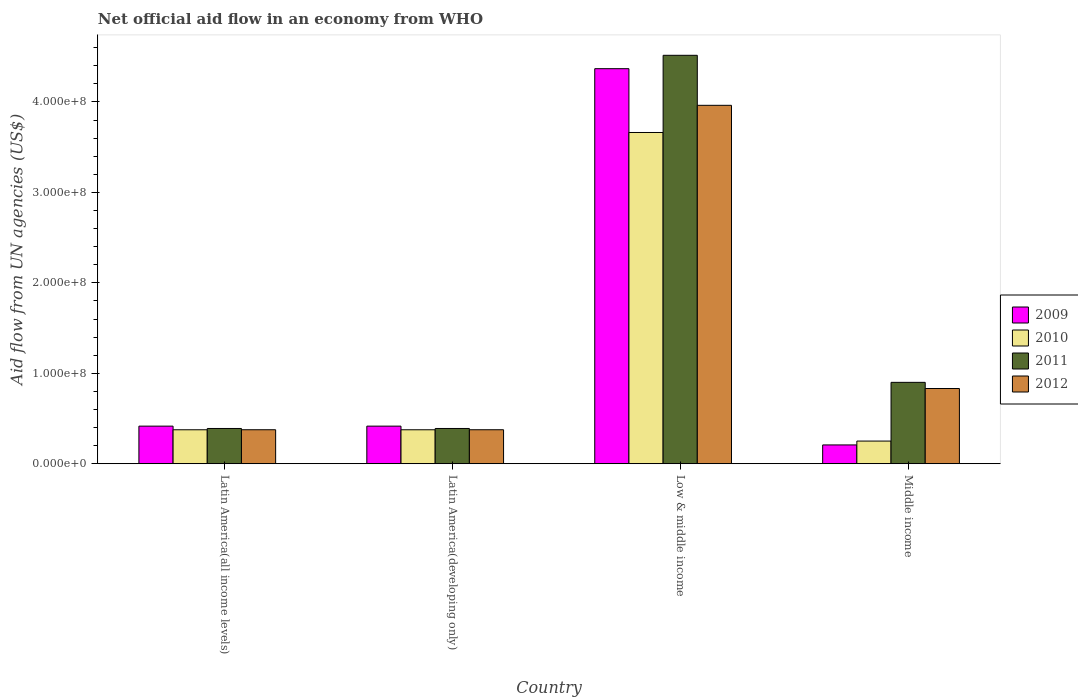How many groups of bars are there?
Offer a very short reply. 4. Are the number of bars per tick equal to the number of legend labels?
Provide a short and direct response. Yes. How many bars are there on the 1st tick from the left?
Offer a terse response. 4. How many bars are there on the 1st tick from the right?
Your response must be concise. 4. What is the label of the 1st group of bars from the left?
Offer a terse response. Latin America(all income levels). What is the net official aid flow in 2010 in Latin America(developing only)?
Provide a succinct answer. 3.76e+07. Across all countries, what is the maximum net official aid flow in 2012?
Your response must be concise. 3.96e+08. Across all countries, what is the minimum net official aid flow in 2009?
Offer a terse response. 2.08e+07. What is the total net official aid flow in 2009 in the graph?
Ensure brevity in your answer.  5.41e+08. What is the difference between the net official aid flow in 2009 in Latin America(all income levels) and that in Latin America(developing only)?
Offer a terse response. 0. What is the difference between the net official aid flow in 2010 in Middle income and the net official aid flow in 2011 in Latin America(all income levels)?
Keep it short and to the point. -1.39e+07. What is the average net official aid flow in 2009 per country?
Give a very brief answer. 1.35e+08. What is the difference between the net official aid flow of/in 2009 and net official aid flow of/in 2012 in Latin America(developing only)?
Provide a succinct answer. 3.99e+06. In how many countries, is the net official aid flow in 2011 greater than 320000000 US$?
Provide a succinct answer. 1. What is the ratio of the net official aid flow in 2009 in Low & middle income to that in Middle income?
Provide a short and direct response. 21. Is the net official aid flow in 2012 in Latin America(developing only) less than that in Low & middle income?
Give a very brief answer. Yes. What is the difference between the highest and the second highest net official aid flow in 2009?
Provide a short and direct response. 3.95e+08. What is the difference between the highest and the lowest net official aid flow in 2010?
Ensure brevity in your answer.  3.41e+08. Is the sum of the net official aid flow in 2010 in Latin America(developing only) and Low & middle income greater than the maximum net official aid flow in 2012 across all countries?
Your response must be concise. Yes. What does the 3rd bar from the left in Latin America(all income levels) represents?
Give a very brief answer. 2011. What does the 4th bar from the right in Middle income represents?
Your response must be concise. 2009. How many bars are there?
Ensure brevity in your answer.  16. Are all the bars in the graph horizontal?
Provide a short and direct response. No. Are the values on the major ticks of Y-axis written in scientific E-notation?
Keep it short and to the point. Yes. Does the graph contain any zero values?
Offer a very short reply. No. How many legend labels are there?
Your answer should be very brief. 4. How are the legend labels stacked?
Offer a terse response. Vertical. What is the title of the graph?
Offer a very short reply. Net official aid flow in an economy from WHO. What is the label or title of the X-axis?
Provide a short and direct response. Country. What is the label or title of the Y-axis?
Ensure brevity in your answer.  Aid flow from UN agencies (US$). What is the Aid flow from UN agencies (US$) in 2009 in Latin America(all income levels)?
Your answer should be very brief. 4.16e+07. What is the Aid flow from UN agencies (US$) of 2010 in Latin America(all income levels)?
Provide a short and direct response. 3.76e+07. What is the Aid flow from UN agencies (US$) of 2011 in Latin America(all income levels)?
Offer a very short reply. 3.90e+07. What is the Aid flow from UN agencies (US$) of 2012 in Latin America(all income levels)?
Your answer should be very brief. 3.76e+07. What is the Aid flow from UN agencies (US$) in 2009 in Latin America(developing only)?
Your answer should be compact. 4.16e+07. What is the Aid flow from UN agencies (US$) in 2010 in Latin America(developing only)?
Your answer should be very brief. 3.76e+07. What is the Aid flow from UN agencies (US$) of 2011 in Latin America(developing only)?
Your answer should be compact. 3.90e+07. What is the Aid flow from UN agencies (US$) of 2012 in Latin America(developing only)?
Your answer should be very brief. 3.76e+07. What is the Aid flow from UN agencies (US$) of 2009 in Low & middle income?
Make the answer very short. 4.37e+08. What is the Aid flow from UN agencies (US$) in 2010 in Low & middle income?
Ensure brevity in your answer.  3.66e+08. What is the Aid flow from UN agencies (US$) of 2011 in Low & middle income?
Keep it short and to the point. 4.52e+08. What is the Aid flow from UN agencies (US$) in 2012 in Low & middle income?
Your response must be concise. 3.96e+08. What is the Aid flow from UN agencies (US$) in 2009 in Middle income?
Your answer should be compact. 2.08e+07. What is the Aid flow from UN agencies (US$) of 2010 in Middle income?
Offer a very short reply. 2.51e+07. What is the Aid flow from UN agencies (US$) of 2011 in Middle income?
Offer a terse response. 9.00e+07. What is the Aid flow from UN agencies (US$) in 2012 in Middle income?
Your answer should be very brief. 8.32e+07. Across all countries, what is the maximum Aid flow from UN agencies (US$) of 2009?
Keep it short and to the point. 4.37e+08. Across all countries, what is the maximum Aid flow from UN agencies (US$) in 2010?
Ensure brevity in your answer.  3.66e+08. Across all countries, what is the maximum Aid flow from UN agencies (US$) of 2011?
Offer a terse response. 4.52e+08. Across all countries, what is the maximum Aid flow from UN agencies (US$) of 2012?
Provide a short and direct response. 3.96e+08. Across all countries, what is the minimum Aid flow from UN agencies (US$) in 2009?
Keep it short and to the point. 2.08e+07. Across all countries, what is the minimum Aid flow from UN agencies (US$) of 2010?
Make the answer very short. 2.51e+07. Across all countries, what is the minimum Aid flow from UN agencies (US$) of 2011?
Give a very brief answer. 3.90e+07. Across all countries, what is the minimum Aid flow from UN agencies (US$) of 2012?
Provide a succinct answer. 3.76e+07. What is the total Aid flow from UN agencies (US$) in 2009 in the graph?
Keep it short and to the point. 5.41e+08. What is the total Aid flow from UN agencies (US$) in 2010 in the graph?
Keep it short and to the point. 4.66e+08. What is the total Aid flow from UN agencies (US$) in 2011 in the graph?
Offer a very short reply. 6.20e+08. What is the total Aid flow from UN agencies (US$) in 2012 in the graph?
Make the answer very short. 5.55e+08. What is the difference between the Aid flow from UN agencies (US$) of 2010 in Latin America(all income levels) and that in Latin America(developing only)?
Make the answer very short. 0. What is the difference between the Aid flow from UN agencies (US$) in 2011 in Latin America(all income levels) and that in Latin America(developing only)?
Your answer should be compact. 0. What is the difference between the Aid flow from UN agencies (US$) in 2009 in Latin America(all income levels) and that in Low & middle income?
Provide a short and direct response. -3.95e+08. What is the difference between the Aid flow from UN agencies (US$) of 2010 in Latin America(all income levels) and that in Low & middle income?
Your answer should be compact. -3.29e+08. What is the difference between the Aid flow from UN agencies (US$) in 2011 in Latin America(all income levels) and that in Low & middle income?
Provide a short and direct response. -4.13e+08. What is the difference between the Aid flow from UN agencies (US$) in 2012 in Latin America(all income levels) and that in Low & middle income?
Provide a succinct answer. -3.59e+08. What is the difference between the Aid flow from UN agencies (US$) of 2009 in Latin America(all income levels) and that in Middle income?
Your answer should be very brief. 2.08e+07. What is the difference between the Aid flow from UN agencies (US$) of 2010 in Latin America(all income levels) and that in Middle income?
Make the answer very short. 1.25e+07. What is the difference between the Aid flow from UN agencies (US$) in 2011 in Latin America(all income levels) and that in Middle income?
Offer a terse response. -5.10e+07. What is the difference between the Aid flow from UN agencies (US$) in 2012 in Latin America(all income levels) and that in Middle income?
Offer a terse response. -4.56e+07. What is the difference between the Aid flow from UN agencies (US$) of 2009 in Latin America(developing only) and that in Low & middle income?
Ensure brevity in your answer.  -3.95e+08. What is the difference between the Aid flow from UN agencies (US$) of 2010 in Latin America(developing only) and that in Low & middle income?
Give a very brief answer. -3.29e+08. What is the difference between the Aid flow from UN agencies (US$) of 2011 in Latin America(developing only) and that in Low & middle income?
Provide a short and direct response. -4.13e+08. What is the difference between the Aid flow from UN agencies (US$) of 2012 in Latin America(developing only) and that in Low & middle income?
Ensure brevity in your answer.  -3.59e+08. What is the difference between the Aid flow from UN agencies (US$) in 2009 in Latin America(developing only) and that in Middle income?
Ensure brevity in your answer.  2.08e+07. What is the difference between the Aid flow from UN agencies (US$) in 2010 in Latin America(developing only) and that in Middle income?
Provide a short and direct response. 1.25e+07. What is the difference between the Aid flow from UN agencies (US$) of 2011 in Latin America(developing only) and that in Middle income?
Make the answer very short. -5.10e+07. What is the difference between the Aid flow from UN agencies (US$) in 2012 in Latin America(developing only) and that in Middle income?
Your answer should be compact. -4.56e+07. What is the difference between the Aid flow from UN agencies (US$) of 2009 in Low & middle income and that in Middle income?
Make the answer very short. 4.16e+08. What is the difference between the Aid flow from UN agencies (US$) of 2010 in Low & middle income and that in Middle income?
Make the answer very short. 3.41e+08. What is the difference between the Aid flow from UN agencies (US$) in 2011 in Low & middle income and that in Middle income?
Keep it short and to the point. 3.62e+08. What is the difference between the Aid flow from UN agencies (US$) in 2012 in Low & middle income and that in Middle income?
Offer a very short reply. 3.13e+08. What is the difference between the Aid flow from UN agencies (US$) in 2009 in Latin America(all income levels) and the Aid flow from UN agencies (US$) in 2010 in Latin America(developing only)?
Offer a terse response. 4.01e+06. What is the difference between the Aid flow from UN agencies (US$) of 2009 in Latin America(all income levels) and the Aid flow from UN agencies (US$) of 2011 in Latin America(developing only)?
Your answer should be very brief. 2.59e+06. What is the difference between the Aid flow from UN agencies (US$) of 2009 in Latin America(all income levels) and the Aid flow from UN agencies (US$) of 2012 in Latin America(developing only)?
Your response must be concise. 3.99e+06. What is the difference between the Aid flow from UN agencies (US$) in 2010 in Latin America(all income levels) and the Aid flow from UN agencies (US$) in 2011 in Latin America(developing only)?
Provide a succinct answer. -1.42e+06. What is the difference between the Aid flow from UN agencies (US$) in 2010 in Latin America(all income levels) and the Aid flow from UN agencies (US$) in 2012 in Latin America(developing only)?
Provide a short and direct response. -2.00e+04. What is the difference between the Aid flow from UN agencies (US$) of 2011 in Latin America(all income levels) and the Aid flow from UN agencies (US$) of 2012 in Latin America(developing only)?
Keep it short and to the point. 1.40e+06. What is the difference between the Aid flow from UN agencies (US$) of 2009 in Latin America(all income levels) and the Aid flow from UN agencies (US$) of 2010 in Low & middle income?
Make the answer very short. -3.25e+08. What is the difference between the Aid flow from UN agencies (US$) of 2009 in Latin America(all income levels) and the Aid flow from UN agencies (US$) of 2011 in Low & middle income?
Offer a terse response. -4.10e+08. What is the difference between the Aid flow from UN agencies (US$) in 2009 in Latin America(all income levels) and the Aid flow from UN agencies (US$) in 2012 in Low & middle income?
Ensure brevity in your answer.  -3.55e+08. What is the difference between the Aid flow from UN agencies (US$) of 2010 in Latin America(all income levels) and the Aid flow from UN agencies (US$) of 2011 in Low & middle income?
Your answer should be very brief. -4.14e+08. What is the difference between the Aid flow from UN agencies (US$) in 2010 in Latin America(all income levels) and the Aid flow from UN agencies (US$) in 2012 in Low & middle income?
Your response must be concise. -3.59e+08. What is the difference between the Aid flow from UN agencies (US$) in 2011 in Latin America(all income levels) and the Aid flow from UN agencies (US$) in 2012 in Low & middle income?
Your answer should be very brief. -3.57e+08. What is the difference between the Aid flow from UN agencies (US$) of 2009 in Latin America(all income levels) and the Aid flow from UN agencies (US$) of 2010 in Middle income?
Offer a terse response. 1.65e+07. What is the difference between the Aid flow from UN agencies (US$) in 2009 in Latin America(all income levels) and the Aid flow from UN agencies (US$) in 2011 in Middle income?
Provide a short and direct response. -4.84e+07. What is the difference between the Aid flow from UN agencies (US$) in 2009 in Latin America(all income levels) and the Aid flow from UN agencies (US$) in 2012 in Middle income?
Your answer should be very brief. -4.16e+07. What is the difference between the Aid flow from UN agencies (US$) of 2010 in Latin America(all income levels) and the Aid flow from UN agencies (US$) of 2011 in Middle income?
Your answer should be compact. -5.24e+07. What is the difference between the Aid flow from UN agencies (US$) in 2010 in Latin America(all income levels) and the Aid flow from UN agencies (US$) in 2012 in Middle income?
Offer a terse response. -4.56e+07. What is the difference between the Aid flow from UN agencies (US$) in 2011 in Latin America(all income levels) and the Aid flow from UN agencies (US$) in 2012 in Middle income?
Offer a very short reply. -4.42e+07. What is the difference between the Aid flow from UN agencies (US$) of 2009 in Latin America(developing only) and the Aid flow from UN agencies (US$) of 2010 in Low & middle income?
Offer a very short reply. -3.25e+08. What is the difference between the Aid flow from UN agencies (US$) in 2009 in Latin America(developing only) and the Aid flow from UN agencies (US$) in 2011 in Low & middle income?
Provide a short and direct response. -4.10e+08. What is the difference between the Aid flow from UN agencies (US$) in 2009 in Latin America(developing only) and the Aid flow from UN agencies (US$) in 2012 in Low & middle income?
Your answer should be compact. -3.55e+08. What is the difference between the Aid flow from UN agencies (US$) in 2010 in Latin America(developing only) and the Aid flow from UN agencies (US$) in 2011 in Low & middle income?
Keep it short and to the point. -4.14e+08. What is the difference between the Aid flow from UN agencies (US$) in 2010 in Latin America(developing only) and the Aid flow from UN agencies (US$) in 2012 in Low & middle income?
Offer a terse response. -3.59e+08. What is the difference between the Aid flow from UN agencies (US$) of 2011 in Latin America(developing only) and the Aid flow from UN agencies (US$) of 2012 in Low & middle income?
Your answer should be compact. -3.57e+08. What is the difference between the Aid flow from UN agencies (US$) of 2009 in Latin America(developing only) and the Aid flow from UN agencies (US$) of 2010 in Middle income?
Offer a terse response. 1.65e+07. What is the difference between the Aid flow from UN agencies (US$) of 2009 in Latin America(developing only) and the Aid flow from UN agencies (US$) of 2011 in Middle income?
Offer a very short reply. -4.84e+07. What is the difference between the Aid flow from UN agencies (US$) of 2009 in Latin America(developing only) and the Aid flow from UN agencies (US$) of 2012 in Middle income?
Offer a very short reply. -4.16e+07. What is the difference between the Aid flow from UN agencies (US$) in 2010 in Latin America(developing only) and the Aid flow from UN agencies (US$) in 2011 in Middle income?
Offer a terse response. -5.24e+07. What is the difference between the Aid flow from UN agencies (US$) in 2010 in Latin America(developing only) and the Aid flow from UN agencies (US$) in 2012 in Middle income?
Your response must be concise. -4.56e+07. What is the difference between the Aid flow from UN agencies (US$) of 2011 in Latin America(developing only) and the Aid flow from UN agencies (US$) of 2012 in Middle income?
Offer a very short reply. -4.42e+07. What is the difference between the Aid flow from UN agencies (US$) in 2009 in Low & middle income and the Aid flow from UN agencies (US$) in 2010 in Middle income?
Provide a short and direct response. 4.12e+08. What is the difference between the Aid flow from UN agencies (US$) in 2009 in Low & middle income and the Aid flow from UN agencies (US$) in 2011 in Middle income?
Your response must be concise. 3.47e+08. What is the difference between the Aid flow from UN agencies (US$) in 2009 in Low & middle income and the Aid flow from UN agencies (US$) in 2012 in Middle income?
Your answer should be compact. 3.54e+08. What is the difference between the Aid flow from UN agencies (US$) in 2010 in Low & middle income and the Aid flow from UN agencies (US$) in 2011 in Middle income?
Provide a succinct answer. 2.76e+08. What is the difference between the Aid flow from UN agencies (US$) in 2010 in Low & middle income and the Aid flow from UN agencies (US$) in 2012 in Middle income?
Your answer should be very brief. 2.83e+08. What is the difference between the Aid flow from UN agencies (US$) in 2011 in Low & middle income and the Aid flow from UN agencies (US$) in 2012 in Middle income?
Your response must be concise. 3.68e+08. What is the average Aid flow from UN agencies (US$) in 2009 per country?
Provide a short and direct response. 1.35e+08. What is the average Aid flow from UN agencies (US$) in 2010 per country?
Ensure brevity in your answer.  1.17e+08. What is the average Aid flow from UN agencies (US$) in 2011 per country?
Ensure brevity in your answer.  1.55e+08. What is the average Aid flow from UN agencies (US$) of 2012 per country?
Offer a terse response. 1.39e+08. What is the difference between the Aid flow from UN agencies (US$) in 2009 and Aid flow from UN agencies (US$) in 2010 in Latin America(all income levels)?
Offer a very short reply. 4.01e+06. What is the difference between the Aid flow from UN agencies (US$) in 2009 and Aid flow from UN agencies (US$) in 2011 in Latin America(all income levels)?
Offer a terse response. 2.59e+06. What is the difference between the Aid flow from UN agencies (US$) of 2009 and Aid flow from UN agencies (US$) of 2012 in Latin America(all income levels)?
Your answer should be very brief. 3.99e+06. What is the difference between the Aid flow from UN agencies (US$) of 2010 and Aid flow from UN agencies (US$) of 2011 in Latin America(all income levels)?
Ensure brevity in your answer.  -1.42e+06. What is the difference between the Aid flow from UN agencies (US$) of 2011 and Aid flow from UN agencies (US$) of 2012 in Latin America(all income levels)?
Provide a succinct answer. 1.40e+06. What is the difference between the Aid flow from UN agencies (US$) of 2009 and Aid flow from UN agencies (US$) of 2010 in Latin America(developing only)?
Offer a very short reply. 4.01e+06. What is the difference between the Aid flow from UN agencies (US$) of 2009 and Aid flow from UN agencies (US$) of 2011 in Latin America(developing only)?
Your answer should be compact. 2.59e+06. What is the difference between the Aid flow from UN agencies (US$) of 2009 and Aid flow from UN agencies (US$) of 2012 in Latin America(developing only)?
Make the answer very short. 3.99e+06. What is the difference between the Aid flow from UN agencies (US$) in 2010 and Aid flow from UN agencies (US$) in 2011 in Latin America(developing only)?
Make the answer very short. -1.42e+06. What is the difference between the Aid flow from UN agencies (US$) of 2011 and Aid flow from UN agencies (US$) of 2012 in Latin America(developing only)?
Make the answer very short. 1.40e+06. What is the difference between the Aid flow from UN agencies (US$) in 2009 and Aid flow from UN agencies (US$) in 2010 in Low & middle income?
Give a very brief answer. 7.06e+07. What is the difference between the Aid flow from UN agencies (US$) in 2009 and Aid flow from UN agencies (US$) in 2011 in Low & middle income?
Keep it short and to the point. -1.48e+07. What is the difference between the Aid flow from UN agencies (US$) of 2009 and Aid flow from UN agencies (US$) of 2012 in Low & middle income?
Make the answer very short. 4.05e+07. What is the difference between the Aid flow from UN agencies (US$) of 2010 and Aid flow from UN agencies (US$) of 2011 in Low & middle income?
Provide a succinct answer. -8.54e+07. What is the difference between the Aid flow from UN agencies (US$) of 2010 and Aid flow from UN agencies (US$) of 2012 in Low & middle income?
Make the answer very short. -3.00e+07. What is the difference between the Aid flow from UN agencies (US$) of 2011 and Aid flow from UN agencies (US$) of 2012 in Low & middle income?
Provide a succinct answer. 5.53e+07. What is the difference between the Aid flow from UN agencies (US$) of 2009 and Aid flow from UN agencies (US$) of 2010 in Middle income?
Your answer should be very brief. -4.27e+06. What is the difference between the Aid flow from UN agencies (US$) in 2009 and Aid flow from UN agencies (US$) in 2011 in Middle income?
Your answer should be very brief. -6.92e+07. What is the difference between the Aid flow from UN agencies (US$) of 2009 and Aid flow from UN agencies (US$) of 2012 in Middle income?
Your answer should be compact. -6.24e+07. What is the difference between the Aid flow from UN agencies (US$) in 2010 and Aid flow from UN agencies (US$) in 2011 in Middle income?
Provide a short and direct response. -6.49e+07. What is the difference between the Aid flow from UN agencies (US$) of 2010 and Aid flow from UN agencies (US$) of 2012 in Middle income?
Your answer should be compact. -5.81e+07. What is the difference between the Aid flow from UN agencies (US$) of 2011 and Aid flow from UN agencies (US$) of 2012 in Middle income?
Ensure brevity in your answer.  6.80e+06. What is the ratio of the Aid flow from UN agencies (US$) in 2009 in Latin America(all income levels) to that in Latin America(developing only)?
Ensure brevity in your answer.  1. What is the ratio of the Aid flow from UN agencies (US$) of 2011 in Latin America(all income levels) to that in Latin America(developing only)?
Provide a short and direct response. 1. What is the ratio of the Aid flow from UN agencies (US$) of 2012 in Latin America(all income levels) to that in Latin America(developing only)?
Offer a terse response. 1. What is the ratio of the Aid flow from UN agencies (US$) in 2009 in Latin America(all income levels) to that in Low & middle income?
Keep it short and to the point. 0.1. What is the ratio of the Aid flow from UN agencies (US$) in 2010 in Latin America(all income levels) to that in Low & middle income?
Your response must be concise. 0.1. What is the ratio of the Aid flow from UN agencies (US$) in 2011 in Latin America(all income levels) to that in Low & middle income?
Keep it short and to the point. 0.09. What is the ratio of the Aid flow from UN agencies (US$) of 2012 in Latin America(all income levels) to that in Low & middle income?
Provide a succinct answer. 0.09. What is the ratio of the Aid flow from UN agencies (US$) of 2009 in Latin America(all income levels) to that in Middle income?
Offer a terse response. 2. What is the ratio of the Aid flow from UN agencies (US$) in 2010 in Latin America(all income levels) to that in Middle income?
Offer a very short reply. 1.5. What is the ratio of the Aid flow from UN agencies (US$) in 2011 in Latin America(all income levels) to that in Middle income?
Provide a succinct answer. 0.43. What is the ratio of the Aid flow from UN agencies (US$) of 2012 in Latin America(all income levels) to that in Middle income?
Make the answer very short. 0.45. What is the ratio of the Aid flow from UN agencies (US$) in 2009 in Latin America(developing only) to that in Low & middle income?
Provide a succinct answer. 0.1. What is the ratio of the Aid flow from UN agencies (US$) in 2010 in Latin America(developing only) to that in Low & middle income?
Provide a succinct answer. 0.1. What is the ratio of the Aid flow from UN agencies (US$) of 2011 in Latin America(developing only) to that in Low & middle income?
Give a very brief answer. 0.09. What is the ratio of the Aid flow from UN agencies (US$) in 2012 in Latin America(developing only) to that in Low & middle income?
Your answer should be compact. 0.09. What is the ratio of the Aid flow from UN agencies (US$) in 2009 in Latin America(developing only) to that in Middle income?
Your answer should be very brief. 2. What is the ratio of the Aid flow from UN agencies (US$) in 2010 in Latin America(developing only) to that in Middle income?
Offer a very short reply. 1.5. What is the ratio of the Aid flow from UN agencies (US$) in 2011 in Latin America(developing only) to that in Middle income?
Your answer should be very brief. 0.43. What is the ratio of the Aid flow from UN agencies (US$) of 2012 in Latin America(developing only) to that in Middle income?
Give a very brief answer. 0.45. What is the ratio of the Aid flow from UN agencies (US$) in 2009 in Low & middle income to that in Middle income?
Provide a succinct answer. 21. What is the ratio of the Aid flow from UN agencies (US$) in 2010 in Low & middle income to that in Middle income?
Provide a short and direct response. 14.61. What is the ratio of the Aid flow from UN agencies (US$) of 2011 in Low & middle income to that in Middle income?
Your answer should be compact. 5.02. What is the ratio of the Aid flow from UN agencies (US$) in 2012 in Low & middle income to that in Middle income?
Offer a terse response. 4.76. What is the difference between the highest and the second highest Aid flow from UN agencies (US$) of 2009?
Ensure brevity in your answer.  3.95e+08. What is the difference between the highest and the second highest Aid flow from UN agencies (US$) of 2010?
Keep it short and to the point. 3.29e+08. What is the difference between the highest and the second highest Aid flow from UN agencies (US$) of 2011?
Offer a terse response. 3.62e+08. What is the difference between the highest and the second highest Aid flow from UN agencies (US$) in 2012?
Provide a succinct answer. 3.13e+08. What is the difference between the highest and the lowest Aid flow from UN agencies (US$) in 2009?
Offer a very short reply. 4.16e+08. What is the difference between the highest and the lowest Aid flow from UN agencies (US$) of 2010?
Provide a succinct answer. 3.41e+08. What is the difference between the highest and the lowest Aid flow from UN agencies (US$) in 2011?
Keep it short and to the point. 4.13e+08. What is the difference between the highest and the lowest Aid flow from UN agencies (US$) in 2012?
Offer a very short reply. 3.59e+08. 